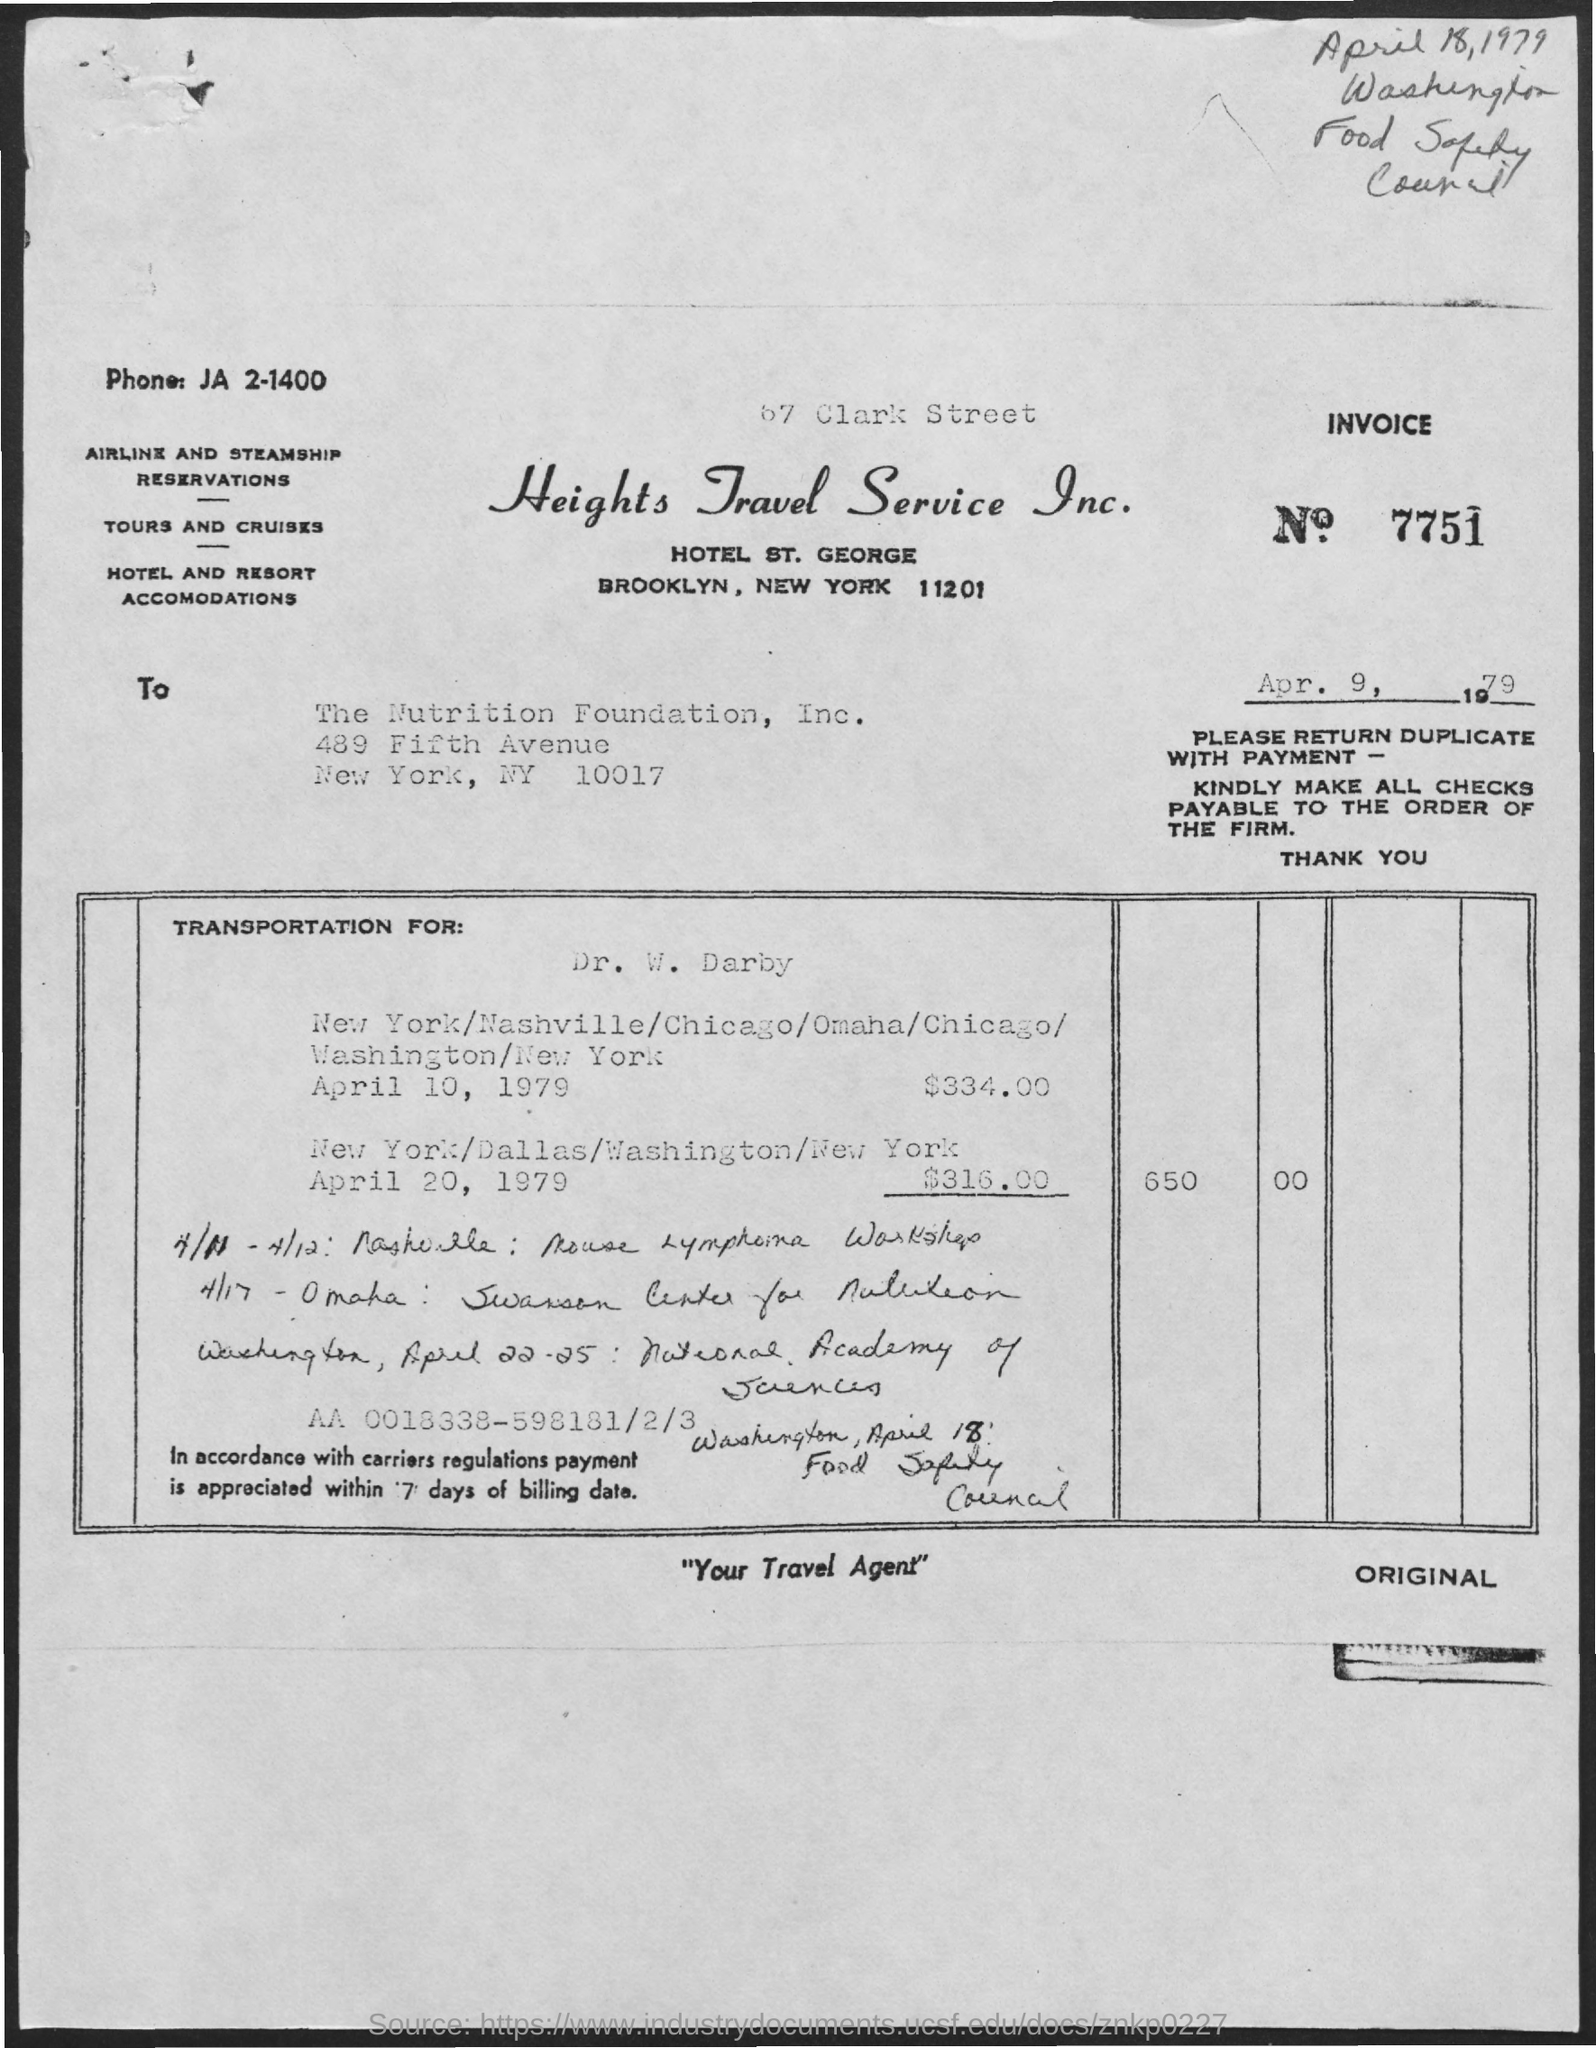What is the Invoice No mentioned in this document?
Keep it short and to the point. 7751. What is the issued date of the invoice?
Make the answer very short. Apr. 9, 1979. To whom, the invoice is addressed?
Ensure brevity in your answer.  The Nutrition Foundation, Inc. What is the Phone no mentioned in the invoice?
Offer a very short reply. JA 2-1400. What is the total invoice amount as per the document?
Provide a succinct answer. 650  00. What is the invoice amount on transportation for Dr. W. Darby dated April 20, 1979?
Your answer should be very brief. $316.00. What is the invoice amount on transportation for Dr. W. Darby dated April 10, 1979?
Give a very brief answer. 334.00. 